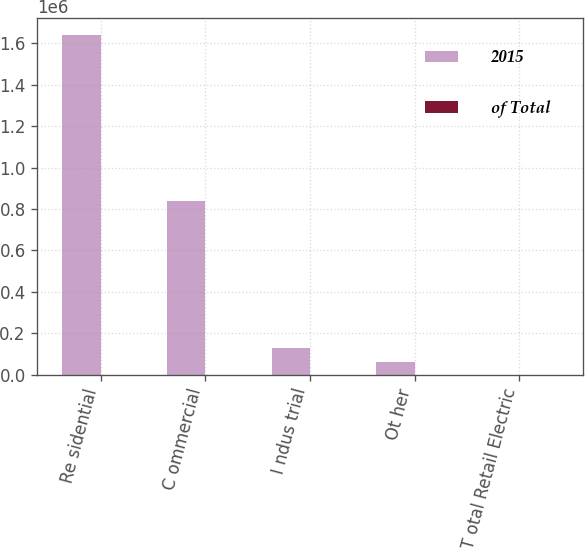<chart> <loc_0><loc_0><loc_500><loc_500><stacked_bar_chart><ecel><fcel>Re sidential<fcel>C ommercial<fcel>I ndus trial<fcel>Ot her<fcel>T otal Retail Electric<nl><fcel>2015<fcel>1.64116e+06<fcel>841093<fcel>129544<fcel>62704<fcel>100<nl><fcel>of Total<fcel>61<fcel>31<fcel>5<fcel>3<fcel>100<nl></chart> 